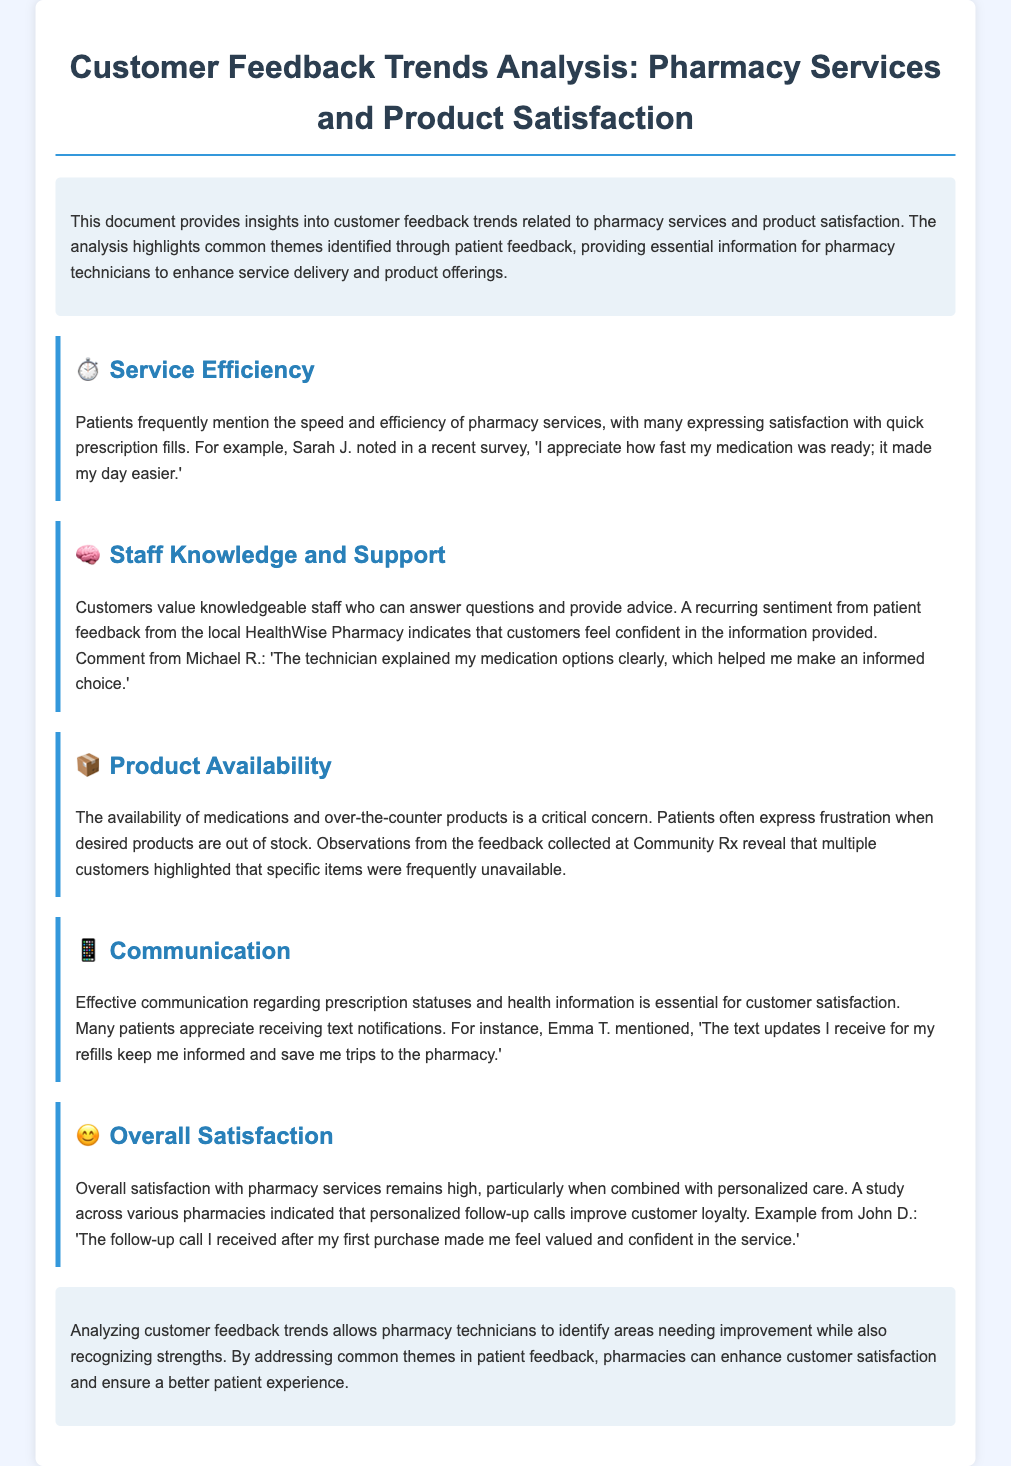What theme is highlighted by the icon ⏱️? The icon ⏱️ represents the theme of Service Efficiency, which patients frequently mention regarding the speed and efficiency of pharmacy services.
Answer: Service Efficiency Who expressed appreciation for quick medication processing? Sarah J. noted her satisfaction with the speed of her medication being ready.
Answer: Sarah J What issue relates to the theme of Product Availability? The theme of Product Availability highlights that patients express frustration when desired products are out of stock.
Answer: Out of stock Which communication method do many patients appreciate for prescription updates? Text notifications are appreciated by many patients for keeping them informed about prescription statuses.
Answer: Text notifications What contributes to high overall satisfaction according to the document? Personalized care, along with follow-up calls, contributes to high overall satisfaction in pharmacy services.
Answer: Personalized care What sentiment did Michael R. express about staff knowledge? Michael R. expressed confidence in the information provided by the staff regarding his medication options.
Answer: Confidence What is a recurring concern mentioned by patients in the theme of Product Availability? Patients frequently highlighted that specific items were often unavailable.
Answer: Specific items unavailable Which factor is essential for customer satisfaction as mentioned in the Communication section? Effective communication regarding prescription statuses and health information is essential for customer satisfaction.
Answer: Effective communication In the Overall Satisfaction theme, what improves customer loyalty? Personalized follow-up calls improve customer loyalty according to the analysis.
Answer: Personalized follow-up calls 